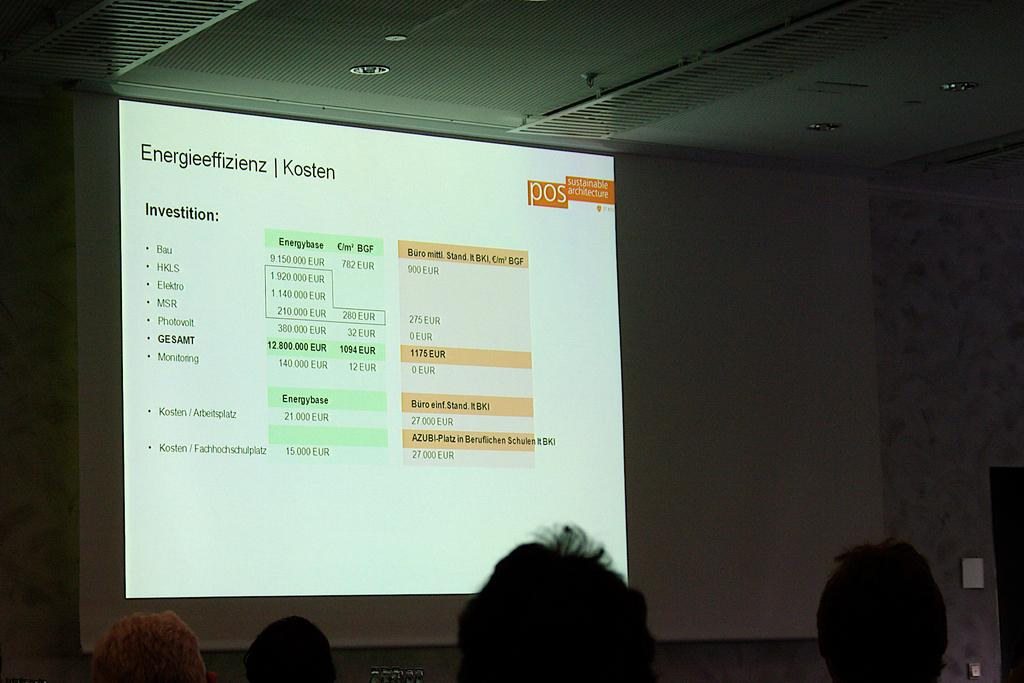Who or what can be seen in the image? There are people in the image. What is the primary object in the image? There is a screen in the image. What type of background is visible in the image? There is a wall in the image. What else can be observed in the image besides the people and screen? There are objects in the image. What type of ornament is hanging from the wall in the image? There is no ornament hanging from the wall in the image; only a screen and people are visible. Can you tell me how many deer are present in the image? There are no deer present in the image. 